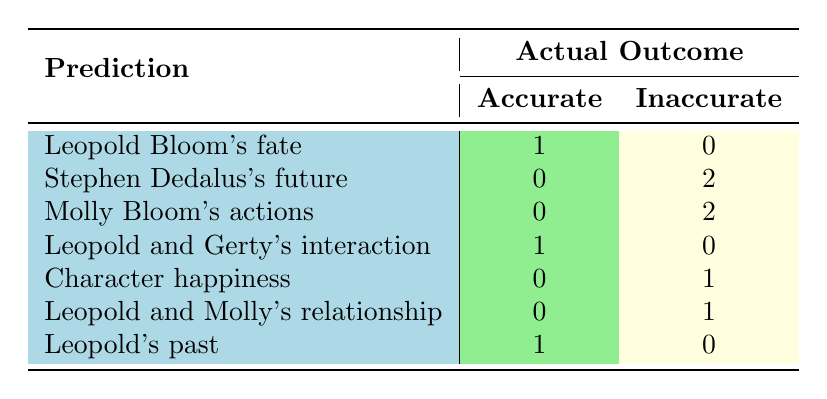What is the total number of accurate predictions in the table? There are a total of 1 accurate prediction for Leopold Bloom's fate, 1 for Leopold and Gerty's interaction, and 1 for Leopold's past. Adding these (1 + 1 + 1) gives a total of 3 accurate predictions.
Answer: 3 How many character outcomes were predicted inaccurately in total? The inaccurate predictions were recorded for Stephen Dedalus (2), Molly Bloom (2), character happiness (1), and Leopold and Molly's relationship (1). Adding these gives (2 + 2 + 1 + 1) = 6 inaccurate predictions in total.
Answer: 6 Did any member accurately predict the outcome for Leopold Bloom? Yes, there is one accurate prediction related to Leopold Bloom’s fate as he finds contentment in his life, which matches Alice’s prediction.
Answer: Yes Which character's fate had the most inaccurate predictions? The character with the most inaccurate predictions is Stephen Dedalus, with 2 inaccurate predictions recorded in the table.
Answer: Stephen Dedalus What percentage of predictions for Molly Bloom's actions were inaccurate? There were 2 predictions made for Molly Bloom's actions, all of which were recorded as inaccurate, leading to a percentage of (2/2)*100 = 100%.
Answer: 100% If we compare the accurate outcomes for Leopold Bloom and Leopold and Gerty’s interaction, how many total accurate predictions are there? Adding the accurate predictions for Leopold Bloom (1) and for Leopold and Gerty (1) gives us (1 + 1 = 2) total accurate predictions.
Answer: 2 Is it true that all predictions relating to character happiness were inaccurate? Yes, the table indicates that there is 1 inaccurate prediction regarding character happiness, confirming that none were accurate.
Answer: Yes How many predictions were made about relationships between characters, and what was their accuracy? There were 2 predictions related to relationships: one about Leopold and Molly, which was inaccurate, and one involving Leopold and Gerty, which was accurate. This indicates that the accuracy is 1/2, or 50%.
Answer: 50% 